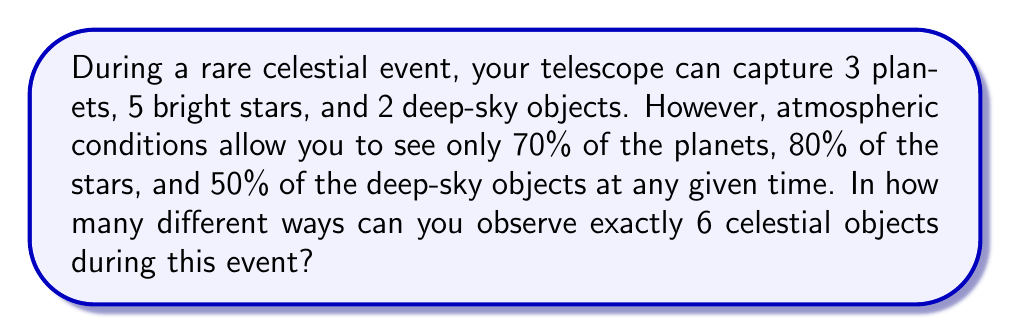What is the answer to this math problem? Let's approach this step-by-step using the concept of combinations and the multiplication principle:

1) First, we need to calculate the number of visible objects in each category:
   - Planets: $3 \times 0.70 = 2.1$, rounded down to 2
   - Stars: $5 \times 0.80 = 4$
   - Deep-sky objects: $2 \times 0.50 = 1$

2) Now, we need to find all possible combinations that sum to 6 objects:
   - 2 planets + 4 stars + 0 deep-sky objects
   - 2 planets + 3 stars + 1 deep-sky object
   - 1 planet + 4 stars + 1 deep-sky object
   - 1 planet + 5 stars + 0 deep-sky objects

3) Let's calculate each combination:
   a) 2 planets + 4 stars + 0 deep-sky objects:
      $$\binom{2}{2} \times \binom{4}{4} \times \binom{1}{0} = 1 \times 1 \times 1 = 1$$

   b) 2 planets + 3 stars + 1 deep-sky object:
      $$\binom{2}{2} \times \binom{4}{3} \times \binom{1}{1} = 1 \times 4 \times 1 = 4$$

   c) 1 planet + 4 stars + 1 deep-sky object:
      $$\binom{2}{1} \times \binom{4}{4} \times \binom{1}{1} = 2 \times 1 \times 1 = 2$$

   d) 1 planet + 5 stars + 0 deep-sky objects:
      $$\binom{2}{1} \times \binom{4}{4} \times \binom{1}{0} = 2 \times 1 \times 1 = 2$$

4) The total number of ways is the sum of all these combinations:
   $$1 + 4 + 2 + 2 = 9$$

Therefore, there are 9 different ways to observe exactly 6 celestial objects during this event.
Answer: 9 